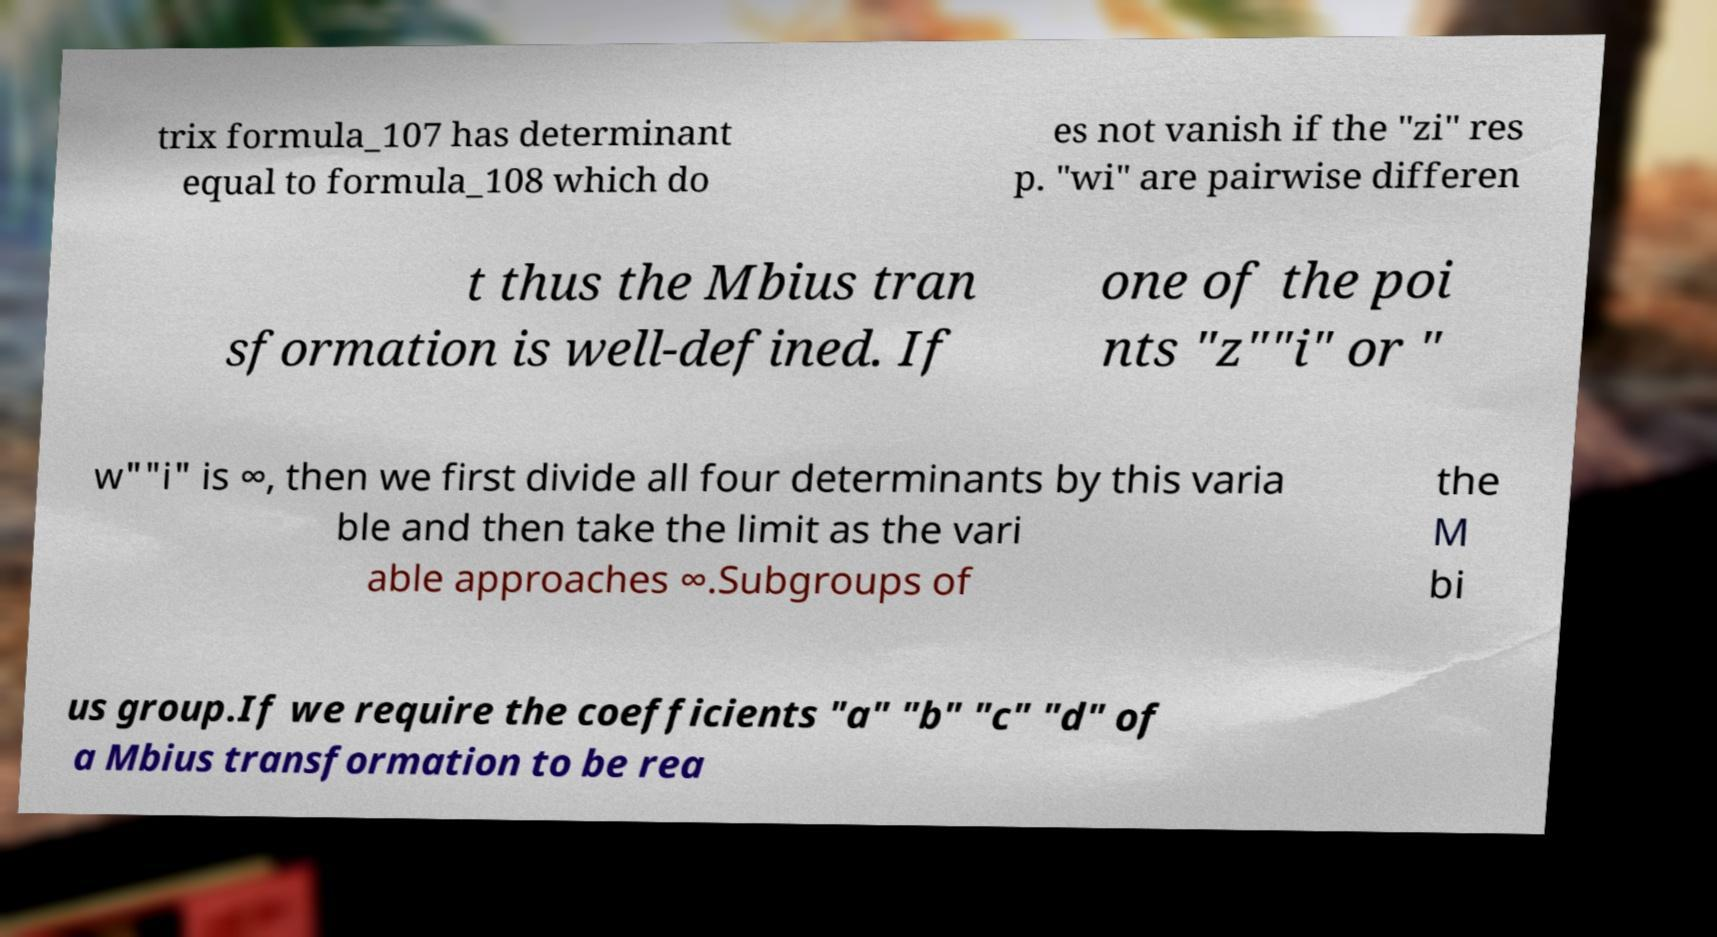There's text embedded in this image that I need extracted. Can you transcribe it verbatim? trix formula_107 has determinant equal to formula_108 which do es not vanish if the "zi" res p. "wi" are pairwise differen t thus the Mbius tran sformation is well-defined. If one of the poi nts "z""i" or " w""i" is ∞, then we first divide all four determinants by this varia ble and then take the limit as the vari able approaches ∞.Subgroups of the M bi us group.If we require the coefficients "a" "b" "c" "d" of a Mbius transformation to be rea 